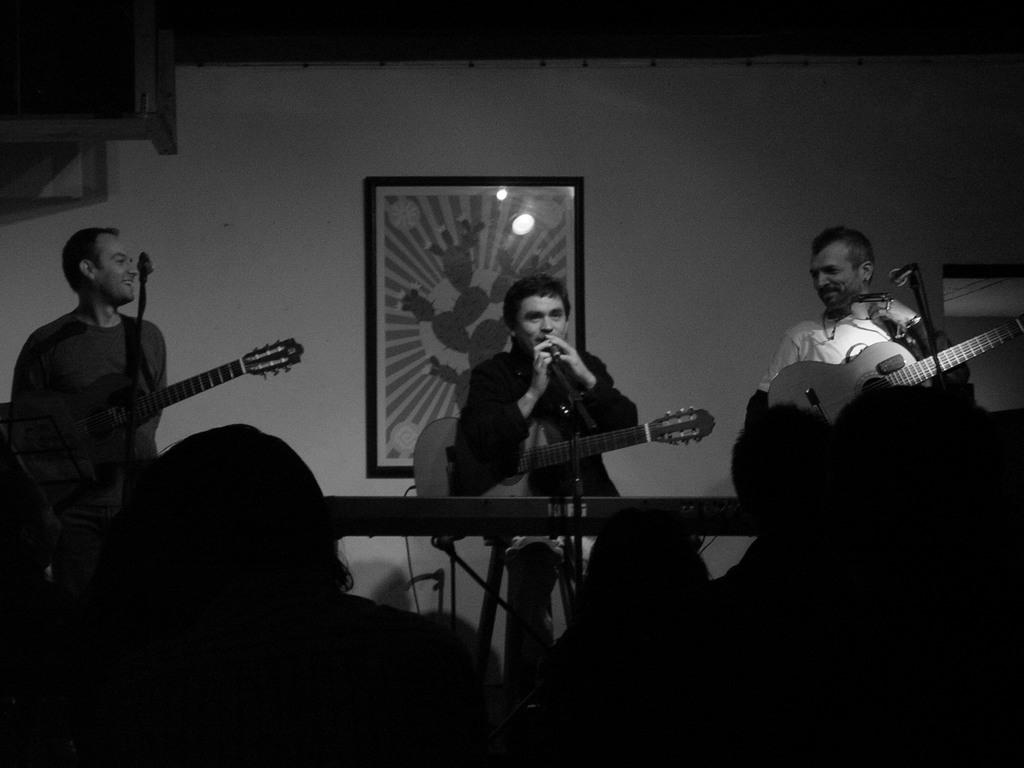How many people are in the image? There are three men in the image. What is one of the men doing in the image? One of the men is sitting in front of a table. What are the men holding in the image? All three men are holding guitars. What type of owl can be seen in the image? There is no owl present in the image. What is the plot of the story being told in the image? The image does not depict a story or plot; it simply shows three men holding guitars. 